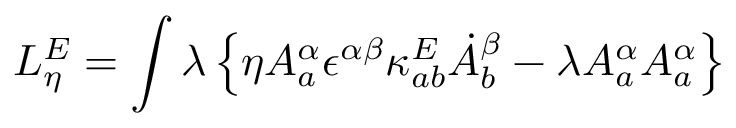Convert formula to latex. <formula><loc_0><loc_0><loc_500><loc_500>L _ { \eta } ^ { E } = \int \lambda \left \{ \eta A _ { a } ^ { \alpha } \epsilon ^ { \alpha \beta } \kappa _ { a b } ^ { E } \dot { A } _ { b } ^ { \beta } - \lambda A _ { a } ^ { \alpha } A _ { a } ^ { \alpha } \right \}</formula> 